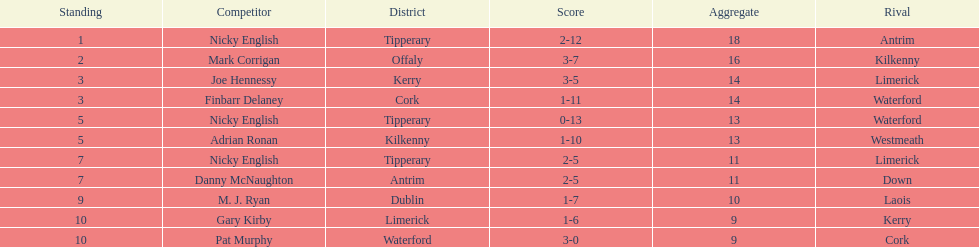How many times was waterford the opposition? 2. 